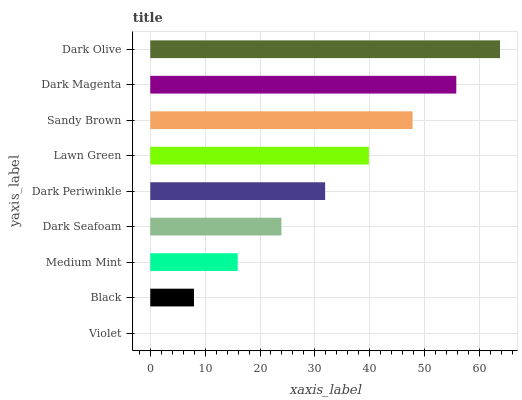Is Violet the minimum?
Answer yes or no. Yes. Is Dark Olive the maximum?
Answer yes or no. Yes. Is Black the minimum?
Answer yes or no. No. Is Black the maximum?
Answer yes or no. No. Is Black greater than Violet?
Answer yes or no. Yes. Is Violet less than Black?
Answer yes or no. Yes. Is Violet greater than Black?
Answer yes or no. No. Is Black less than Violet?
Answer yes or no. No. Is Dark Periwinkle the high median?
Answer yes or no. Yes. Is Dark Periwinkle the low median?
Answer yes or no. Yes. Is Dark Magenta the high median?
Answer yes or no. No. Is Dark Olive the low median?
Answer yes or no. No. 